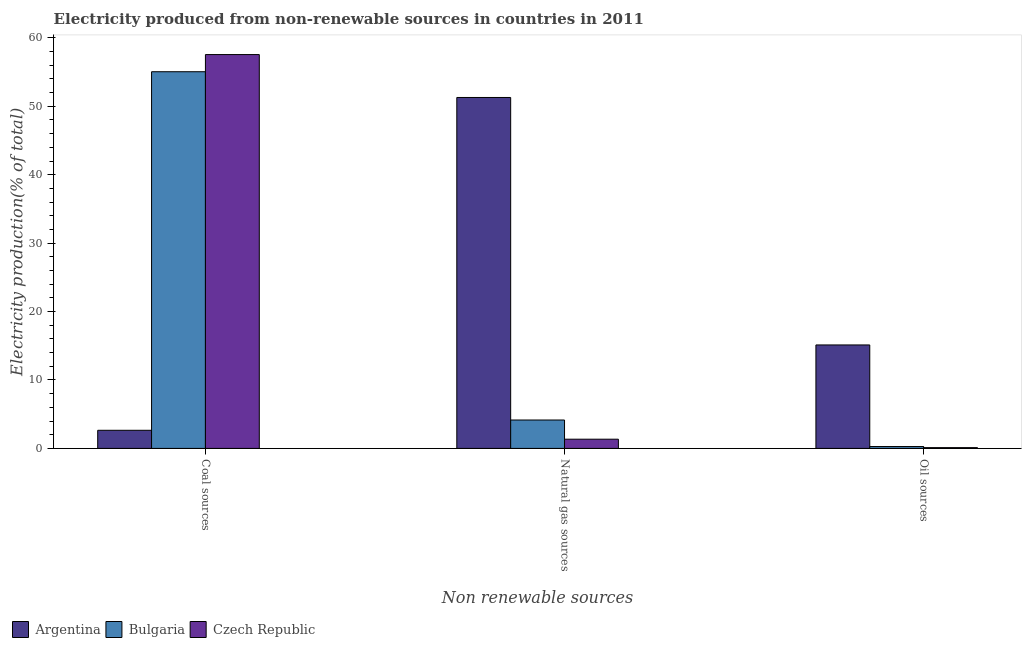How many different coloured bars are there?
Provide a succinct answer. 3. Are the number of bars on each tick of the X-axis equal?
Your answer should be compact. Yes. How many bars are there on the 3rd tick from the left?
Your answer should be compact. 3. How many bars are there on the 2nd tick from the right?
Provide a short and direct response. 3. What is the label of the 2nd group of bars from the left?
Your answer should be compact. Natural gas sources. What is the percentage of electricity produced by oil sources in Bulgaria?
Your answer should be very brief. 0.27. Across all countries, what is the maximum percentage of electricity produced by coal?
Give a very brief answer. 57.56. Across all countries, what is the minimum percentage of electricity produced by coal?
Offer a terse response. 2.65. In which country was the percentage of electricity produced by coal maximum?
Ensure brevity in your answer.  Czech Republic. In which country was the percentage of electricity produced by oil sources minimum?
Make the answer very short. Czech Republic. What is the total percentage of electricity produced by natural gas in the graph?
Offer a very short reply. 56.79. What is the difference between the percentage of electricity produced by coal in Argentina and that in Czech Republic?
Your answer should be compact. -54.91. What is the difference between the percentage of electricity produced by coal in Czech Republic and the percentage of electricity produced by oil sources in Argentina?
Provide a succinct answer. 42.44. What is the average percentage of electricity produced by coal per country?
Your response must be concise. 38.42. What is the difference between the percentage of electricity produced by oil sources and percentage of electricity produced by natural gas in Bulgaria?
Your response must be concise. -3.88. What is the ratio of the percentage of electricity produced by coal in Czech Republic to that in Bulgaria?
Make the answer very short. 1.05. Is the percentage of electricity produced by coal in Argentina less than that in Czech Republic?
Your response must be concise. Yes. Is the difference between the percentage of electricity produced by coal in Bulgaria and Argentina greater than the difference between the percentage of electricity produced by oil sources in Bulgaria and Argentina?
Provide a short and direct response. Yes. What is the difference between the highest and the second highest percentage of electricity produced by natural gas?
Make the answer very short. 47.13. What is the difference between the highest and the lowest percentage of electricity produced by coal?
Make the answer very short. 54.91. What does the 2nd bar from the left in Oil sources represents?
Ensure brevity in your answer.  Bulgaria. What does the 1st bar from the right in Natural gas sources represents?
Your answer should be compact. Czech Republic. Is it the case that in every country, the sum of the percentage of electricity produced by coal and percentage of electricity produced by natural gas is greater than the percentage of electricity produced by oil sources?
Make the answer very short. Yes. How many bars are there?
Your response must be concise. 9. Are all the bars in the graph horizontal?
Your answer should be compact. No. How many countries are there in the graph?
Your answer should be very brief. 3. What is the difference between two consecutive major ticks on the Y-axis?
Give a very brief answer. 10. Does the graph contain any zero values?
Keep it short and to the point. No. Does the graph contain grids?
Your answer should be compact. No. Where does the legend appear in the graph?
Your answer should be very brief. Bottom left. How are the legend labels stacked?
Give a very brief answer. Horizontal. What is the title of the graph?
Offer a very short reply. Electricity produced from non-renewable sources in countries in 2011. Does "Timor-Leste" appear as one of the legend labels in the graph?
Your answer should be compact. No. What is the label or title of the X-axis?
Make the answer very short. Non renewable sources. What is the Electricity production(% of total) of Argentina in Coal sources?
Your answer should be compact. 2.65. What is the Electricity production(% of total) in Bulgaria in Coal sources?
Offer a very short reply. 55.05. What is the Electricity production(% of total) in Czech Republic in Coal sources?
Your answer should be compact. 57.56. What is the Electricity production(% of total) in Argentina in Natural gas sources?
Your answer should be very brief. 51.29. What is the Electricity production(% of total) in Bulgaria in Natural gas sources?
Give a very brief answer. 4.15. What is the Electricity production(% of total) in Czech Republic in Natural gas sources?
Your answer should be compact. 1.35. What is the Electricity production(% of total) in Argentina in Oil sources?
Provide a short and direct response. 15.12. What is the Electricity production(% of total) of Bulgaria in Oil sources?
Your response must be concise. 0.27. What is the Electricity production(% of total) in Czech Republic in Oil sources?
Offer a terse response. 0.11. Across all Non renewable sources, what is the maximum Electricity production(% of total) in Argentina?
Your answer should be compact. 51.29. Across all Non renewable sources, what is the maximum Electricity production(% of total) in Bulgaria?
Keep it short and to the point. 55.05. Across all Non renewable sources, what is the maximum Electricity production(% of total) in Czech Republic?
Offer a terse response. 57.56. Across all Non renewable sources, what is the minimum Electricity production(% of total) of Argentina?
Offer a terse response. 2.65. Across all Non renewable sources, what is the minimum Electricity production(% of total) of Bulgaria?
Your answer should be compact. 0.27. Across all Non renewable sources, what is the minimum Electricity production(% of total) in Czech Republic?
Give a very brief answer. 0.11. What is the total Electricity production(% of total) of Argentina in the graph?
Give a very brief answer. 69.06. What is the total Electricity production(% of total) of Bulgaria in the graph?
Give a very brief answer. 59.47. What is the total Electricity production(% of total) in Czech Republic in the graph?
Your answer should be very brief. 59.02. What is the difference between the Electricity production(% of total) of Argentina in Coal sources and that in Natural gas sources?
Ensure brevity in your answer.  -48.64. What is the difference between the Electricity production(% of total) in Bulgaria in Coal sources and that in Natural gas sources?
Ensure brevity in your answer.  50.9. What is the difference between the Electricity production(% of total) of Czech Republic in Coal sources and that in Natural gas sources?
Offer a terse response. 56.21. What is the difference between the Electricity production(% of total) in Argentina in Coal sources and that in Oil sources?
Keep it short and to the point. -12.47. What is the difference between the Electricity production(% of total) in Bulgaria in Coal sources and that in Oil sources?
Provide a short and direct response. 54.77. What is the difference between the Electricity production(% of total) of Czech Republic in Coal sources and that in Oil sources?
Give a very brief answer. 57.44. What is the difference between the Electricity production(% of total) in Argentina in Natural gas sources and that in Oil sources?
Keep it short and to the point. 36.16. What is the difference between the Electricity production(% of total) of Bulgaria in Natural gas sources and that in Oil sources?
Provide a short and direct response. 3.88. What is the difference between the Electricity production(% of total) of Czech Republic in Natural gas sources and that in Oil sources?
Your response must be concise. 1.23. What is the difference between the Electricity production(% of total) in Argentina in Coal sources and the Electricity production(% of total) in Bulgaria in Natural gas sources?
Offer a very short reply. -1.5. What is the difference between the Electricity production(% of total) of Argentina in Coal sources and the Electricity production(% of total) of Czech Republic in Natural gas sources?
Keep it short and to the point. 1.3. What is the difference between the Electricity production(% of total) of Bulgaria in Coal sources and the Electricity production(% of total) of Czech Republic in Natural gas sources?
Give a very brief answer. 53.7. What is the difference between the Electricity production(% of total) of Argentina in Coal sources and the Electricity production(% of total) of Bulgaria in Oil sources?
Your answer should be very brief. 2.38. What is the difference between the Electricity production(% of total) in Argentina in Coal sources and the Electricity production(% of total) in Czech Republic in Oil sources?
Keep it short and to the point. 2.54. What is the difference between the Electricity production(% of total) of Bulgaria in Coal sources and the Electricity production(% of total) of Czech Republic in Oil sources?
Offer a very short reply. 54.93. What is the difference between the Electricity production(% of total) in Argentina in Natural gas sources and the Electricity production(% of total) in Bulgaria in Oil sources?
Ensure brevity in your answer.  51.01. What is the difference between the Electricity production(% of total) of Argentina in Natural gas sources and the Electricity production(% of total) of Czech Republic in Oil sources?
Your answer should be very brief. 51.17. What is the difference between the Electricity production(% of total) in Bulgaria in Natural gas sources and the Electricity production(% of total) in Czech Republic in Oil sources?
Offer a very short reply. 4.04. What is the average Electricity production(% of total) in Argentina per Non renewable sources?
Make the answer very short. 23.02. What is the average Electricity production(% of total) in Bulgaria per Non renewable sources?
Make the answer very short. 19.82. What is the average Electricity production(% of total) of Czech Republic per Non renewable sources?
Provide a short and direct response. 19.67. What is the difference between the Electricity production(% of total) in Argentina and Electricity production(% of total) in Bulgaria in Coal sources?
Your response must be concise. -52.4. What is the difference between the Electricity production(% of total) in Argentina and Electricity production(% of total) in Czech Republic in Coal sources?
Give a very brief answer. -54.91. What is the difference between the Electricity production(% of total) in Bulgaria and Electricity production(% of total) in Czech Republic in Coal sources?
Make the answer very short. -2.51. What is the difference between the Electricity production(% of total) in Argentina and Electricity production(% of total) in Bulgaria in Natural gas sources?
Ensure brevity in your answer.  47.13. What is the difference between the Electricity production(% of total) of Argentina and Electricity production(% of total) of Czech Republic in Natural gas sources?
Your answer should be compact. 49.94. What is the difference between the Electricity production(% of total) of Bulgaria and Electricity production(% of total) of Czech Republic in Natural gas sources?
Provide a succinct answer. 2.8. What is the difference between the Electricity production(% of total) of Argentina and Electricity production(% of total) of Bulgaria in Oil sources?
Provide a short and direct response. 14.85. What is the difference between the Electricity production(% of total) of Argentina and Electricity production(% of total) of Czech Republic in Oil sources?
Keep it short and to the point. 15.01. What is the difference between the Electricity production(% of total) in Bulgaria and Electricity production(% of total) in Czech Republic in Oil sources?
Provide a short and direct response. 0.16. What is the ratio of the Electricity production(% of total) in Argentina in Coal sources to that in Natural gas sources?
Ensure brevity in your answer.  0.05. What is the ratio of the Electricity production(% of total) in Bulgaria in Coal sources to that in Natural gas sources?
Ensure brevity in your answer.  13.26. What is the ratio of the Electricity production(% of total) of Czech Republic in Coal sources to that in Natural gas sources?
Provide a succinct answer. 42.69. What is the ratio of the Electricity production(% of total) of Argentina in Coal sources to that in Oil sources?
Give a very brief answer. 0.18. What is the ratio of the Electricity production(% of total) in Bulgaria in Coal sources to that in Oil sources?
Offer a very short reply. 201. What is the ratio of the Electricity production(% of total) of Czech Republic in Coal sources to that in Oil sources?
Provide a short and direct response. 504.99. What is the ratio of the Electricity production(% of total) in Argentina in Natural gas sources to that in Oil sources?
Provide a short and direct response. 3.39. What is the ratio of the Electricity production(% of total) of Bulgaria in Natural gas sources to that in Oil sources?
Ensure brevity in your answer.  15.16. What is the ratio of the Electricity production(% of total) in Czech Republic in Natural gas sources to that in Oil sources?
Provide a succinct answer. 11.83. What is the difference between the highest and the second highest Electricity production(% of total) in Argentina?
Offer a terse response. 36.16. What is the difference between the highest and the second highest Electricity production(% of total) of Bulgaria?
Your answer should be very brief. 50.9. What is the difference between the highest and the second highest Electricity production(% of total) in Czech Republic?
Your answer should be compact. 56.21. What is the difference between the highest and the lowest Electricity production(% of total) in Argentina?
Provide a succinct answer. 48.64. What is the difference between the highest and the lowest Electricity production(% of total) of Bulgaria?
Your answer should be very brief. 54.77. What is the difference between the highest and the lowest Electricity production(% of total) of Czech Republic?
Provide a succinct answer. 57.44. 